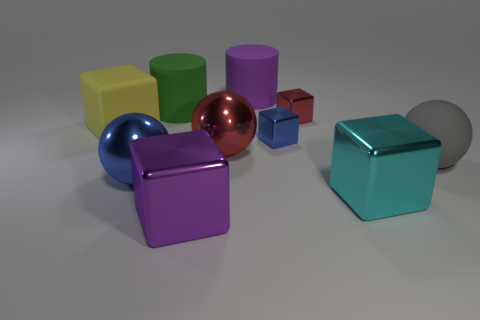Subtract all yellow matte blocks. How many blocks are left? 4 Subtract all blue blocks. How many blocks are left? 4 Subtract 3 blocks. How many blocks are left? 2 Subtract all small gray metallic balls. Subtract all small red metallic things. How many objects are left? 9 Add 6 red spheres. How many red spheres are left? 7 Add 4 big cyan balls. How many big cyan balls exist? 4 Subtract 0 green cubes. How many objects are left? 10 Subtract all cylinders. How many objects are left? 8 Subtract all purple blocks. Subtract all yellow spheres. How many blocks are left? 4 